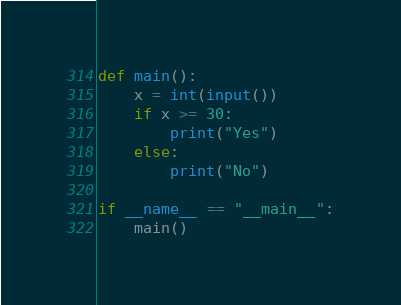<code> <loc_0><loc_0><loc_500><loc_500><_Python_>def main():
    x = int(input())
    if x >= 30:
        print("Yes")
    else:
        print("No")

if __name__ == "__main__":
    main()</code> 